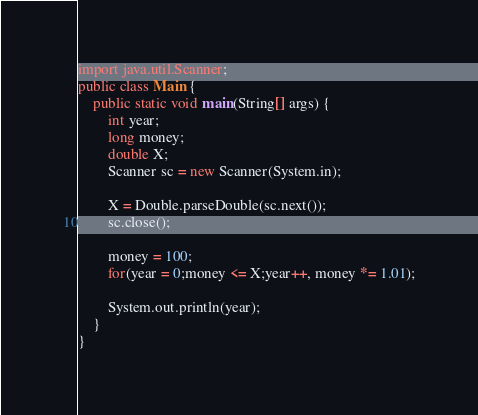<code> <loc_0><loc_0><loc_500><loc_500><_Java_>import java.util.Scanner;
public class Main {
	public static void main(String[] args) {
		int year;
		long money;
		double X;
		Scanner sc = new Scanner(System.in);
		
		X = Double.parseDouble(sc.next());
		sc.close();
		
		money = 100;
		for(year = 0;money <= X;year++, money *= 1.01);
		
		System.out.println(year);
	}
}
</code> 